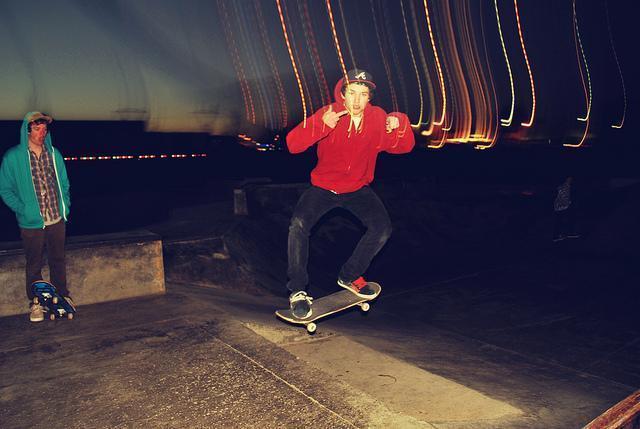The boy skateboarding is a fan of what baseball team?
Select the correct answer and articulate reasoning with the following format: 'Answer: answer
Rationale: rationale.'
Options: Atlanta braves, montreal expos, detroit tigers, edmonton oilers. Answer: atlanta braves.
Rationale: The boy has a braves hat on. 